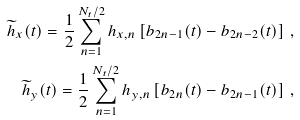<formula> <loc_0><loc_0><loc_500><loc_500>\widetilde { h } _ { x } ( t ) = \frac { 1 } { 2 } \sum _ { n = 1 } ^ { N _ { t } / 2 } h _ { x , n } \left [ b _ { 2 n - 1 } ( t ) - b _ { 2 n - 2 } ( t ) \right ] \, , \\ \widetilde { h } _ { y } ( t ) = \frac { 1 } { 2 } \sum _ { n = 1 } ^ { N _ { t } / 2 } h _ { y , n } \left [ b _ { 2 n } ( t ) - b _ { 2 n - 1 } ( t ) \right ] \, ,</formula> 